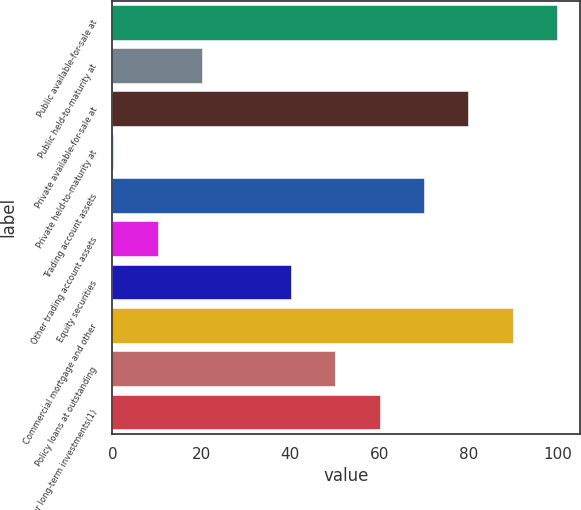Convert chart to OTSL. <chart><loc_0><loc_0><loc_500><loc_500><bar_chart><fcel>Public available-for-sale at<fcel>Public held-to-maturity at<fcel>Private available-for-sale at<fcel>Private held-to-maturity at<fcel>Trading account assets<fcel>Other trading account assets<fcel>Equity securities<fcel>Commercial mortgage and other<fcel>Policy loans at outstanding<fcel>Other long-term investments(1)<nl><fcel>100<fcel>20.16<fcel>80.04<fcel>0.2<fcel>70.06<fcel>10.18<fcel>40.12<fcel>90.02<fcel>50.1<fcel>60.08<nl></chart> 